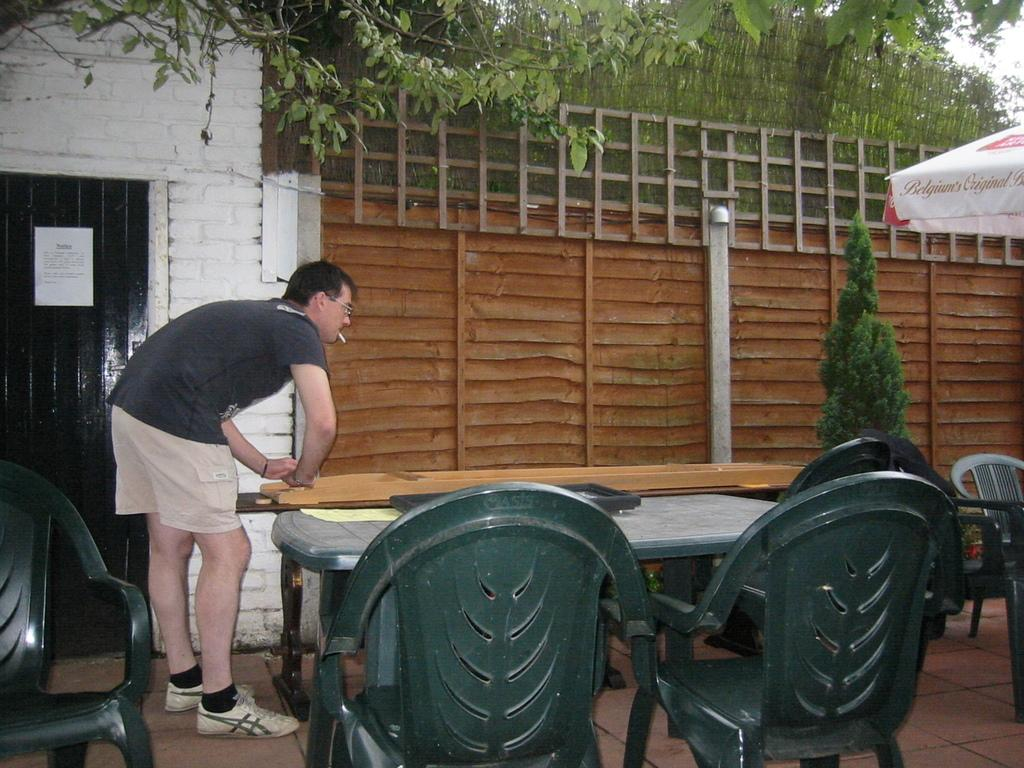What type of furniture is present in the image? There are chairs and tables in the image. Can you describe the person in the image? The person is standing and smoking. What type of shelter is visible in the image? There is a tent in the image. What can be seen in the background of the image? There is a wall, a tree, and a wooden fence in the background of the image. What is the tax rate for the transportation of goods in the image? There is no information about tax or transportation of goods in the image, as it primarily features chairs, tables, a person smoking, a tent, and various background elements. 